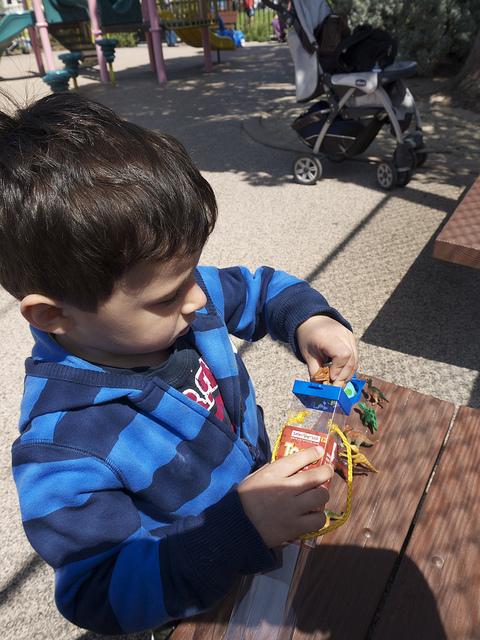How many women are in the picture?
Give a very brief answer. 0. Who is the subject?
Quick response, please. Boy. What other object is in the picture?
Answer briefly. Stroller. 